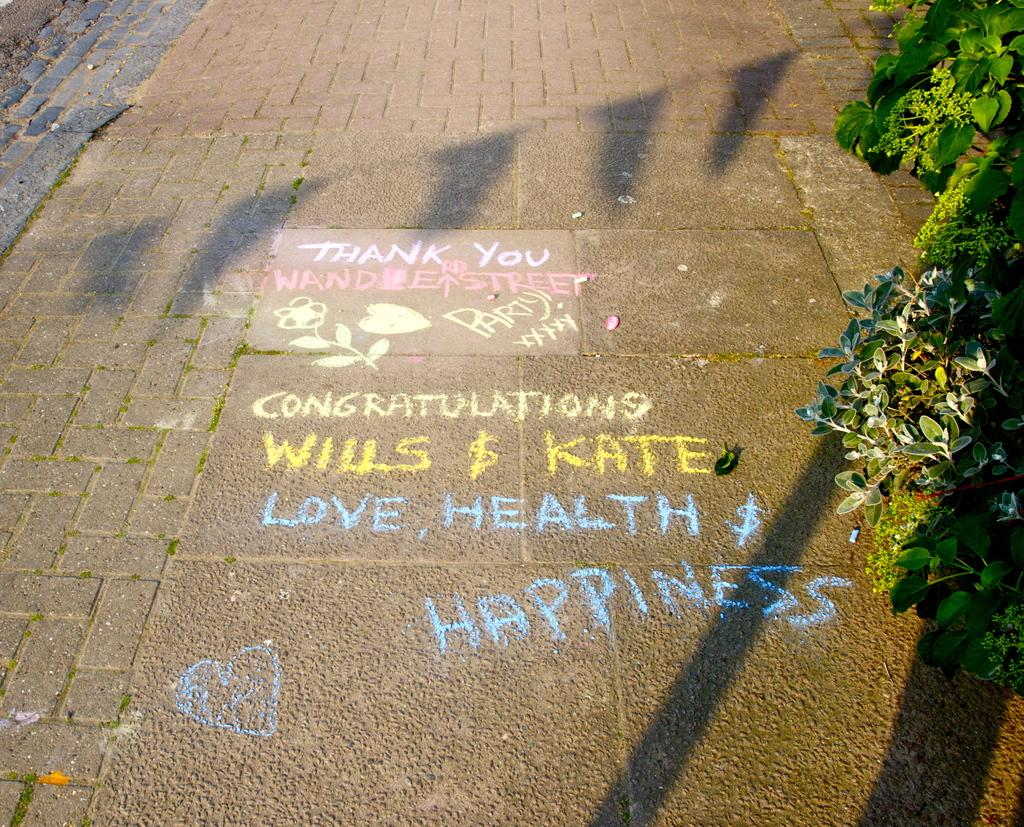What can be found in the image that contains information or ideas? There is written text in the image. What can be seen on the ground in the image? There are drawings on the ground in the image. What type of vegetation is on the right side of the image? There are plants on the right side of the image. What type of wine is being served in the image? There is no wine present in the image. What statement does the uncle make in the image? There is no uncle or statement present in the image. 